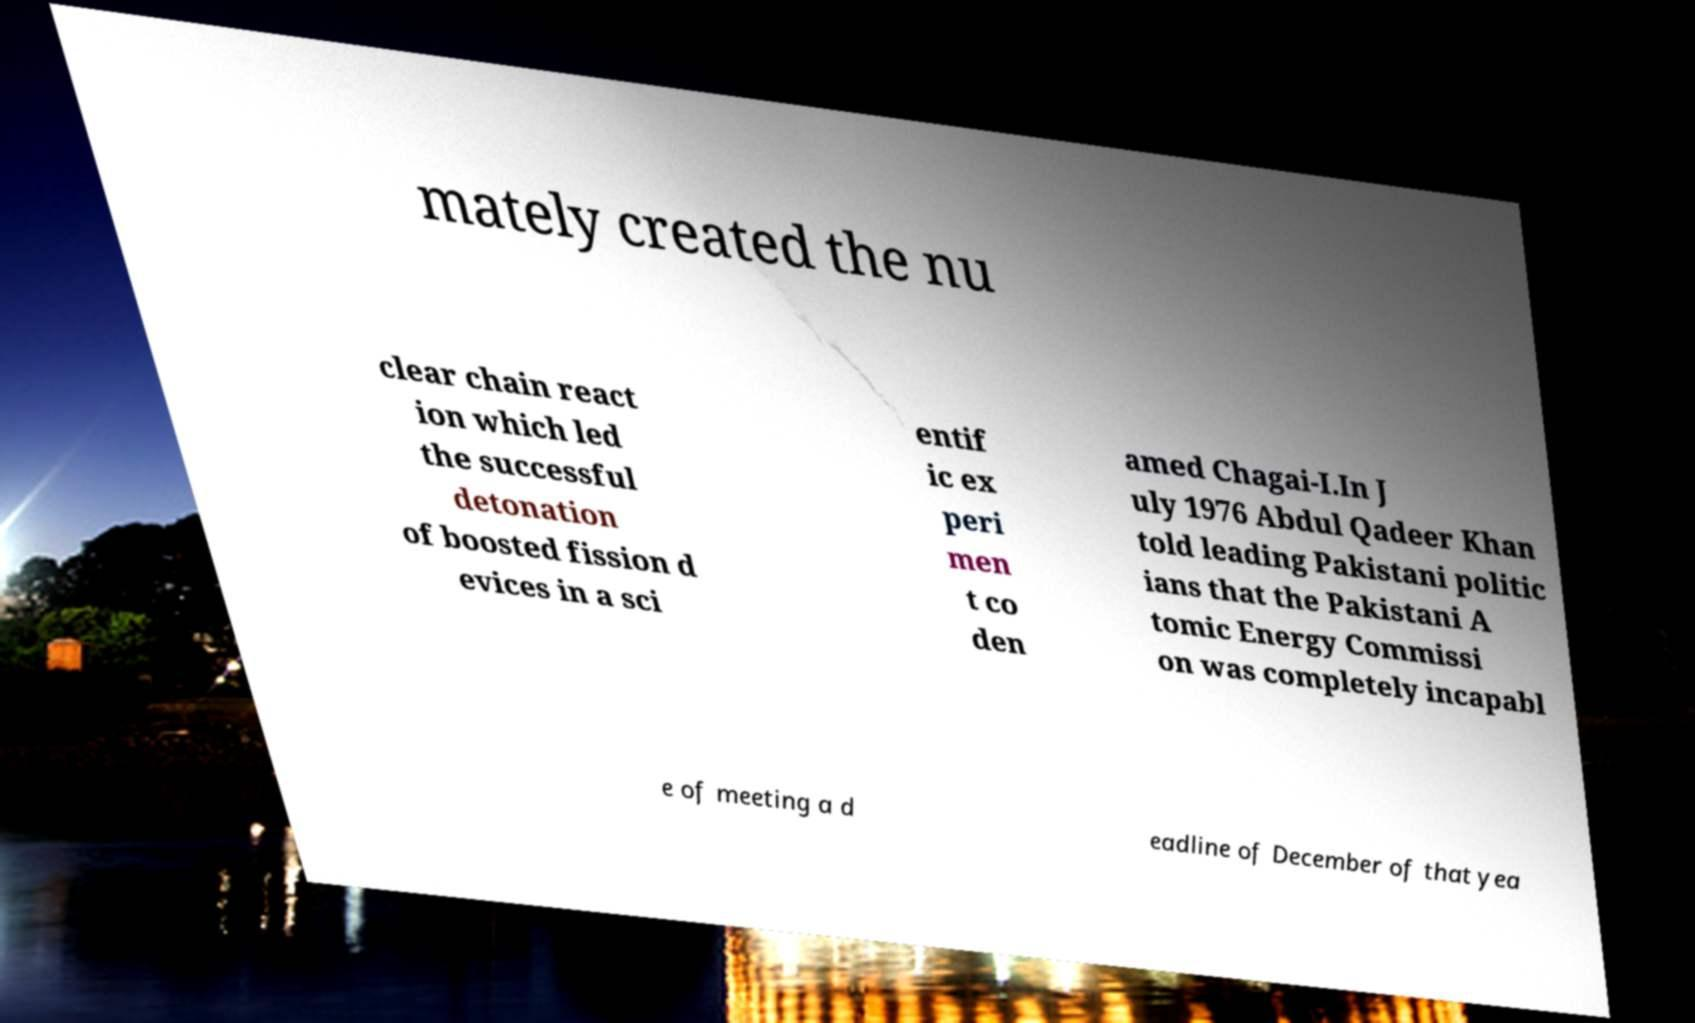Could you assist in decoding the text presented in this image and type it out clearly? mately created the nu clear chain react ion which led the successful detonation of boosted fission d evices in a sci entif ic ex peri men t co den amed Chagai-I.In J uly 1976 Abdul Qadeer Khan told leading Pakistani politic ians that the Pakistani A tomic Energy Commissi on was completely incapabl e of meeting a d eadline of December of that yea 